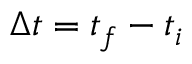Convert formula to latex. <formula><loc_0><loc_0><loc_500><loc_500>\Delta t = t _ { f } - t _ { i }</formula> 